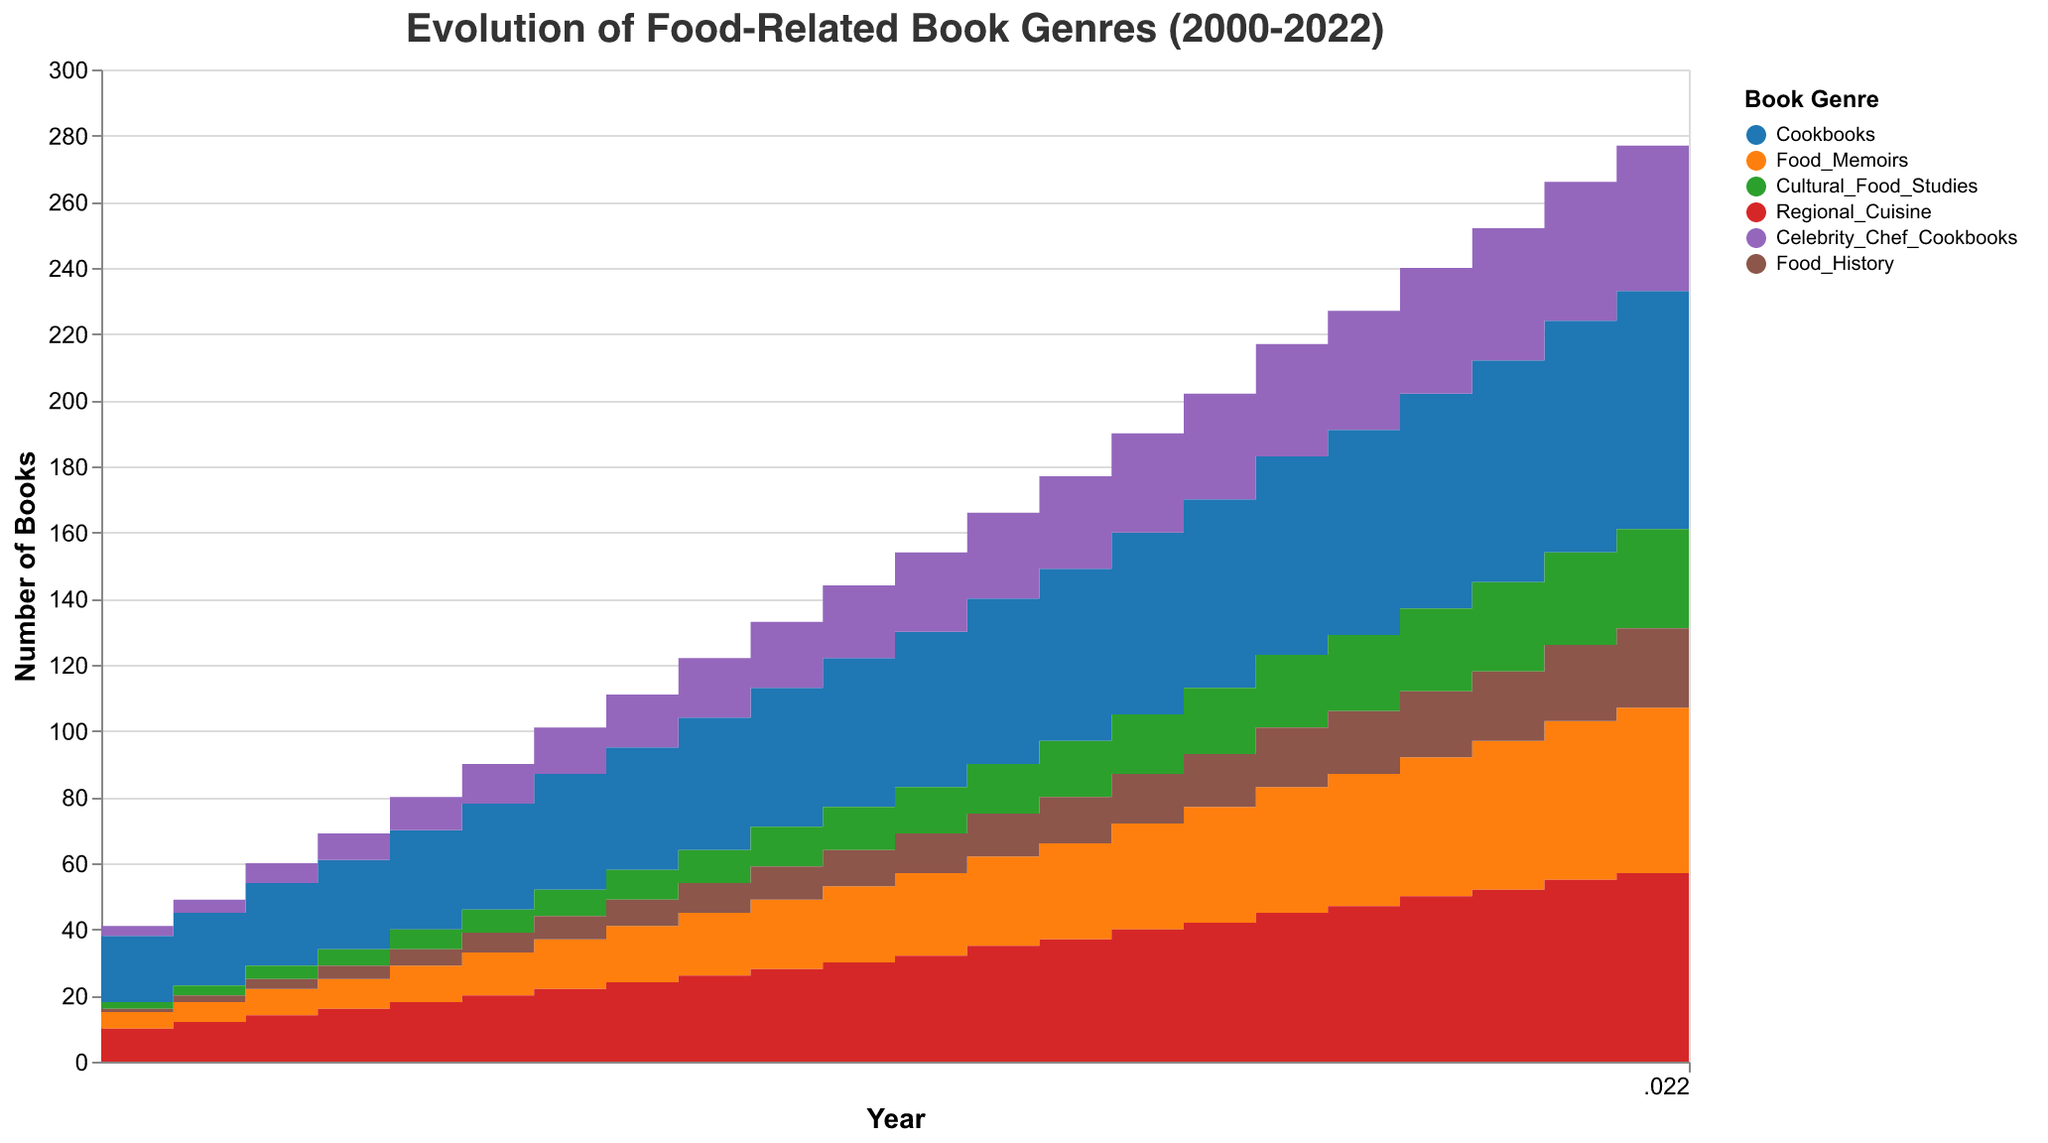What is the title of the chart? The title of the chart is displayed at the top.
Answer: Evolution of Food-Related Book Genres (2000-2022) What is the most published genre in 2022? Look at the data for the year 2022 and identify the genre with the highest value from the stacked areas.
Answer: Cookbooks How many Cookbooks were published in 2010? Refer to the "Cookbooks" category for the year 2010 on the x-axis and follow it up vertically to read the value.
Answer: 45 What genre saw the highest increase in the number of books from 2000 to 2022? Compare the increments of each genre by subtracting the 2000 values from the 2022 values for all genres. The genre with the highest increase will be the answer.
Answer: Cookbooks By how much did Food Memoirs increase from 2000 to 2022? Subtract the number of Food Memoirs published in 2000 from the number published in 2022.
Answer: 47 Which genre had more books published in 2015: Food Memoirs or Cultural Food Studies? Compare the vertical heights of the two areas for 2015.
Answer: Food Memoirs What is the trend of Celebrity Chef Cookbooks from 2000 to 2022? Observe the area representing Celebrity Chef Cookbooks to see if it generally increases, decreases, or stays constant over time.
Answer: Increasing trend In which year did Regional Cuisine exceed 50 publications? Check the area representing Regional Cuisine and find the year where the value first crosses the 50-mark on the y-axis.
Answer: 2018 What's the total number of books published in 2005? Sum up the values of all genres for the year 2005.
Answer: 90 Which genre had the smallest count throughout the entire period? Identify the genre with the smallest values across all the years by examining the areas in the chart.
Answer: Food History 